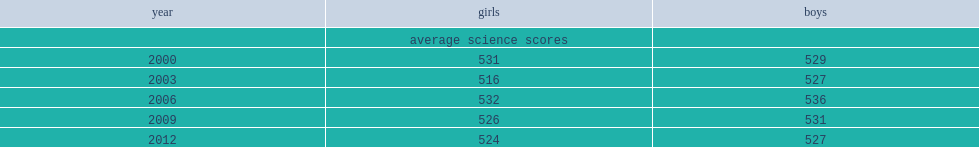What were the science scores of girls and boys in 2012 respectively? 524.0 527.0. 